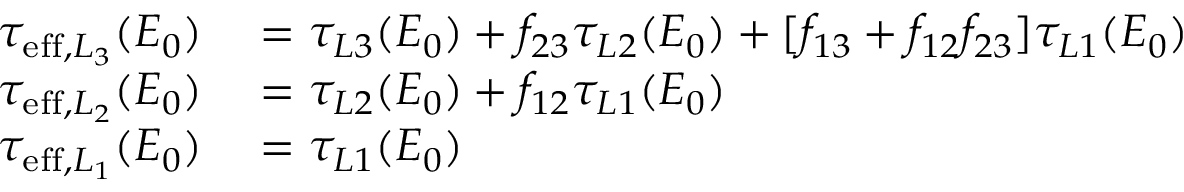Convert formula to latex. <formula><loc_0><loc_0><loc_500><loc_500>\begin{array} { r l } { \tau _ { e f f , L _ { 3 } } ( E _ { 0 } ) } & = \tau _ { L 3 } ( E _ { 0 } ) + f _ { 2 3 } \tau _ { L 2 } ( E _ { 0 } ) + [ f _ { 1 3 } + f _ { 1 2 } f _ { 2 3 } ] \tau _ { L 1 } ( E _ { 0 } ) } \\ { \tau _ { e f f , L _ { 2 } } ( E _ { 0 } ) } & = \tau _ { L 2 } ( E _ { 0 } ) + f _ { 1 2 } \tau _ { L 1 } ( E _ { 0 } ) } \\ { \tau _ { e f f , L _ { 1 } } ( E _ { 0 } ) } & = \tau _ { L 1 } ( E _ { 0 } ) } \end{array}</formula> 